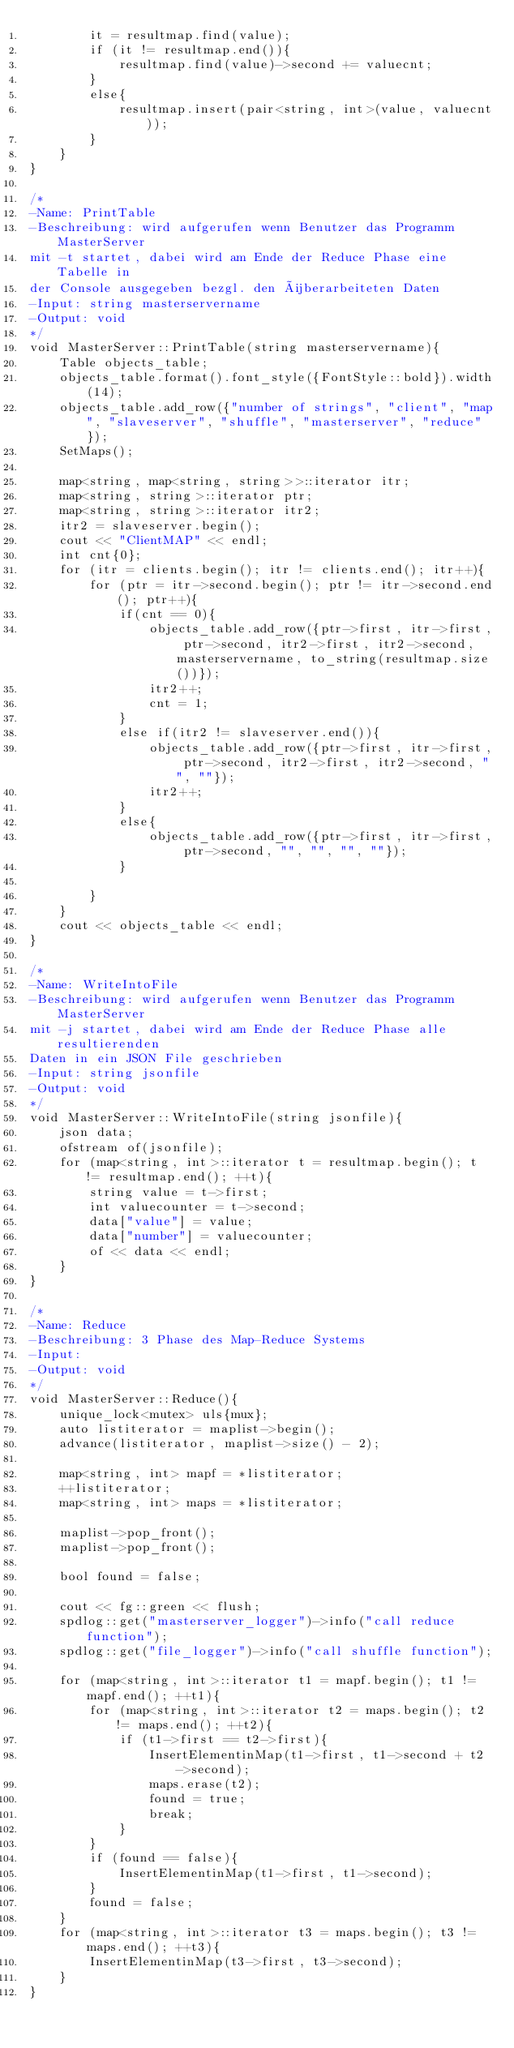<code> <loc_0><loc_0><loc_500><loc_500><_C++_>        it = resultmap.find(value);
        if (it != resultmap.end()){
            resultmap.find(value)->second += valuecnt;
        }
        else{
            resultmap.insert(pair<string, int>(value, valuecnt));
        }
    }
}

/*
-Name: PrintTable
-Beschreibung: wird aufgerufen wenn Benutzer das Programm MasterServer
mit -t startet, dabei wird am Ende der Reduce Phase eine Tabelle in
der Console ausgegeben bezgl. den überarbeiteten Daten
-Input: string masterservername
-Output: void     
*/
void MasterServer::PrintTable(string masterservername){
    Table objects_table;
    objects_table.format().font_style({FontStyle::bold}).width(14);
    objects_table.add_row({"number of strings", "client", "map", "slaveserver", "shuffle", "masterserver", "reduce"});
    SetMaps();

    map<string, map<string, string>>::iterator itr;
    map<string, string>::iterator ptr;
    map<string, string>::iterator itr2;
    itr2 = slaveserver.begin();
    cout << "ClientMAP" << endl;
    int cnt{0};
    for (itr = clients.begin(); itr != clients.end(); itr++){
        for (ptr = itr->second.begin(); ptr != itr->second.end(); ptr++){
            if(cnt == 0){
                objects_table.add_row({ptr->first, itr->first, ptr->second, itr2->first, itr2->second, masterservername, to_string(resultmap.size())});
                itr2++;
                cnt = 1;
            }
            else if(itr2 != slaveserver.end()){
                objects_table.add_row({ptr->first, itr->first, ptr->second, itr2->first, itr2->second, "", ""});
                itr2++;
            }
            else{
                objects_table.add_row({ptr->first, itr->first, ptr->second, "", "", "", ""});
            }
            
        }
    }
    cout << objects_table << endl;
}

/*
-Name: WriteIntoFile
-Beschreibung: wird aufgerufen wenn Benutzer das Programm MasterServer
mit -j startet, dabei wird am Ende der Reduce Phase alle resultierenden
Daten in ein JSON File geschrieben
-Input: string jsonfile
-Output: void      
*/
void MasterServer::WriteIntoFile(string jsonfile){
    json data;
    ofstream of(jsonfile);
    for (map<string, int>::iterator t = resultmap.begin(); t != resultmap.end(); ++t){
        string value = t->first;
        int valuecounter = t->second;
        data["value"] = value;
        data["number"] = valuecounter;
        of << data << endl;
    }
}

/*
-Name: Reduce
-Beschreibung: 3 Phase des Map-Reduce Systems
-Input: 
-Output: void      
*/
void MasterServer::Reduce(){
    unique_lock<mutex> uls{mux};
    auto listiterator = maplist->begin();
    advance(listiterator, maplist->size() - 2);

    map<string, int> mapf = *listiterator;
    ++listiterator;
    map<string, int> maps = *listiterator;

    maplist->pop_front();
    maplist->pop_front();

    bool found = false;

    cout << fg::green << flush;
    spdlog::get("masterserver_logger")->info("call reduce function");
    spdlog::get("file_logger")->info("call shuffle function");

    for (map<string, int>::iterator t1 = mapf.begin(); t1 != mapf.end(); ++t1){
        for (map<string, int>::iterator t2 = maps.begin(); t2 != maps.end(); ++t2){
            if (t1->first == t2->first){
                InsertElementinMap(t1->first, t1->second + t2->second);
                maps.erase(t2);
                found = true;
                break;
            }
        }
        if (found == false){
            InsertElementinMap(t1->first, t1->second);
        }
        found = false;
    }
    for (map<string, int>::iterator t3 = maps.begin(); t3 != maps.end(); ++t3){
        InsertElementinMap(t3->first, t3->second);
    }
}


</code> 